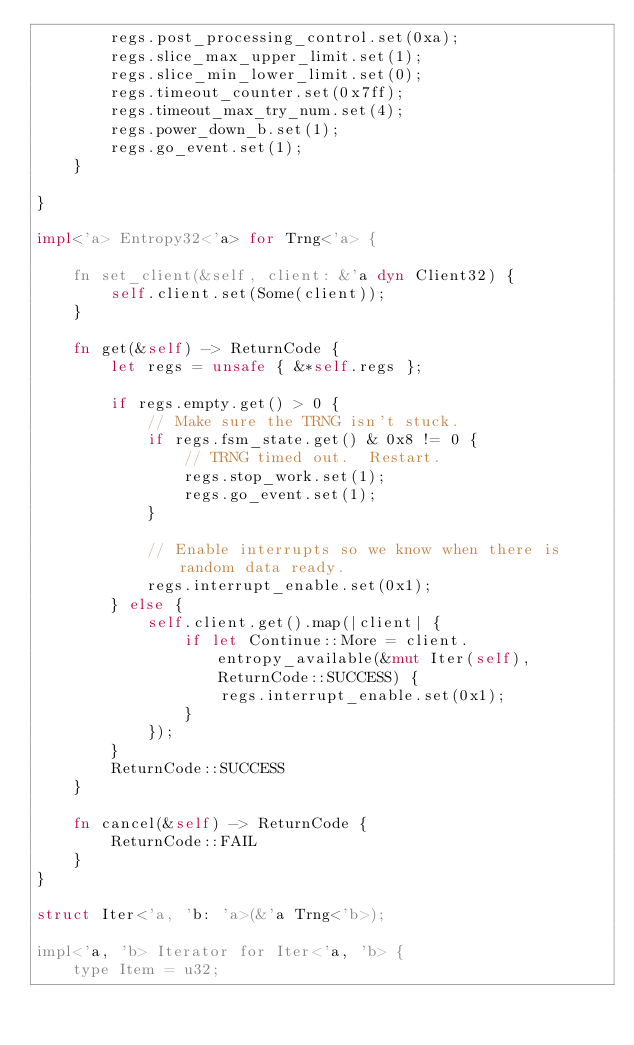Convert code to text. <code><loc_0><loc_0><loc_500><loc_500><_Rust_>        regs.post_processing_control.set(0xa);
        regs.slice_max_upper_limit.set(1);
        regs.slice_min_lower_limit.set(0);
        regs.timeout_counter.set(0x7ff);
        regs.timeout_max_try_num.set(4);
        regs.power_down_b.set(1);
        regs.go_event.set(1);
    }

}

impl<'a> Entropy32<'a> for Trng<'a> {

    fn set_client(&self, client: &'a dyn Client32) {
        self.client.set(Some(client));
    }

    fn get(&self) -> ReturnCode {
        let regs = unsafe { &*self.regs };

        if regs.empty.get() > 0 {
            // Make sure the TRNG isn't stuck.
            if regs.fsm_state.get() & 0x8 != 0 {
                // TRNG timed out.  Restart.
                regs.stop_work.set(1);
                regs.go_event.set(1);
            }

            // Enable interrupts so we know when there is random data ready.
            regs.interrupt_enable.set(0x1);
        } else {
            self.client.get().map(|client| {
                if let Continue::More = client.entropy_available(&mut Iter(self), ReturnCode::SUCCESS) {
                    regs.interrupt_enable.set(0x1);
                }
            });
        }
        ReturnCode::SUCCESS
    }

    fn cancel(&self) -> ReturnCode {
        ReturnCode::FAIL
    }
}

struct Iter<'a, 'b: 'a>(&'a Trng<'b>);

impl<'a, 'b> Iterator for Iter<'a, 'b> {
    type Item = u32;
</code> 